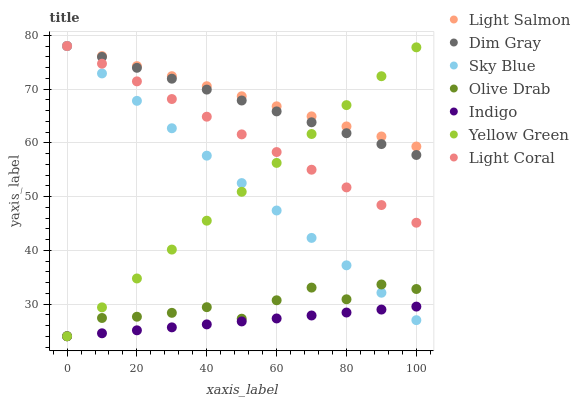Does Indigo have the minimum area under the curve?
Answer yes or no. Yes. Does Light Salmon have the maximum area under the curve?
Answer yes or no. Yes. Does Dim Gray have the minimum area under the curve?
Answer yes or no. No. Does Dim Gray have the maximum area under the curve?
Answer yes or no. No. Is Indigo the smoothest?
Answer yes or no. Yes. Is Olive Drab the roughest?
Answer yes or no. Yes. Is Dim Gray the smoothest?
Answer yes or no. No. Is Dim Gray the roughest?
Answer yes or no. No. Does Indigo have the lowest value?
Answer yes or no. Yes. Does Dim Gray have the lowest value?
Answer yes or no. No. Does Sky Blue have the highest value?
Answer yes or no. Yes. Does Indigo have the highest value?
Answer yes or no. No. Is Olive Drab less than Dim Gray?
Answer yes or no. Yes. Is Light Salmon greater than Indigo?
Answer yes or no. Yes. Does Light Coral intersect Light Salmon?
Answer yes or no. Yes. Is Light Coral less than Light Salmon?
Answer yes or no. No. Is Light Coral greater than Light Salmon?
Answer yes or no. No. Does Olive Drab intersect Dim Gray?
Answer yes or no. No. 